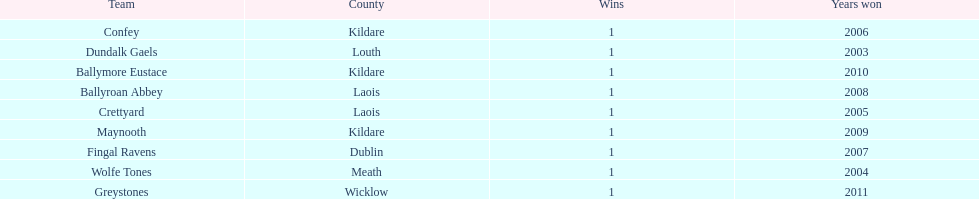How many wins did confey have? 1. 